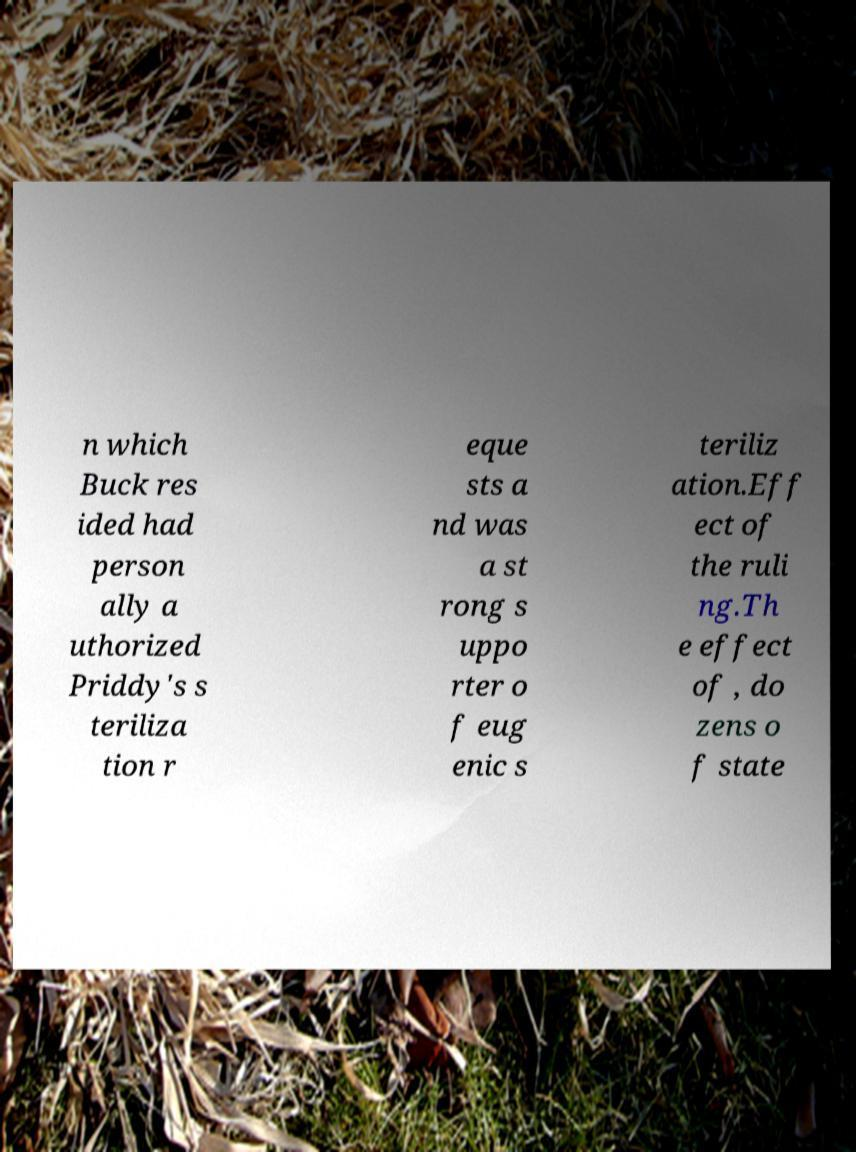Please identify and transcribe the text found in this image. n which Buck res ided had person ally a uthorized Priddy's s teriliza tion r eque sts a nd was a st rong s uppo rter o f eug enic s teriliz ation.Eff ect of the ruli ng.Th e effect of , do zens o f state 